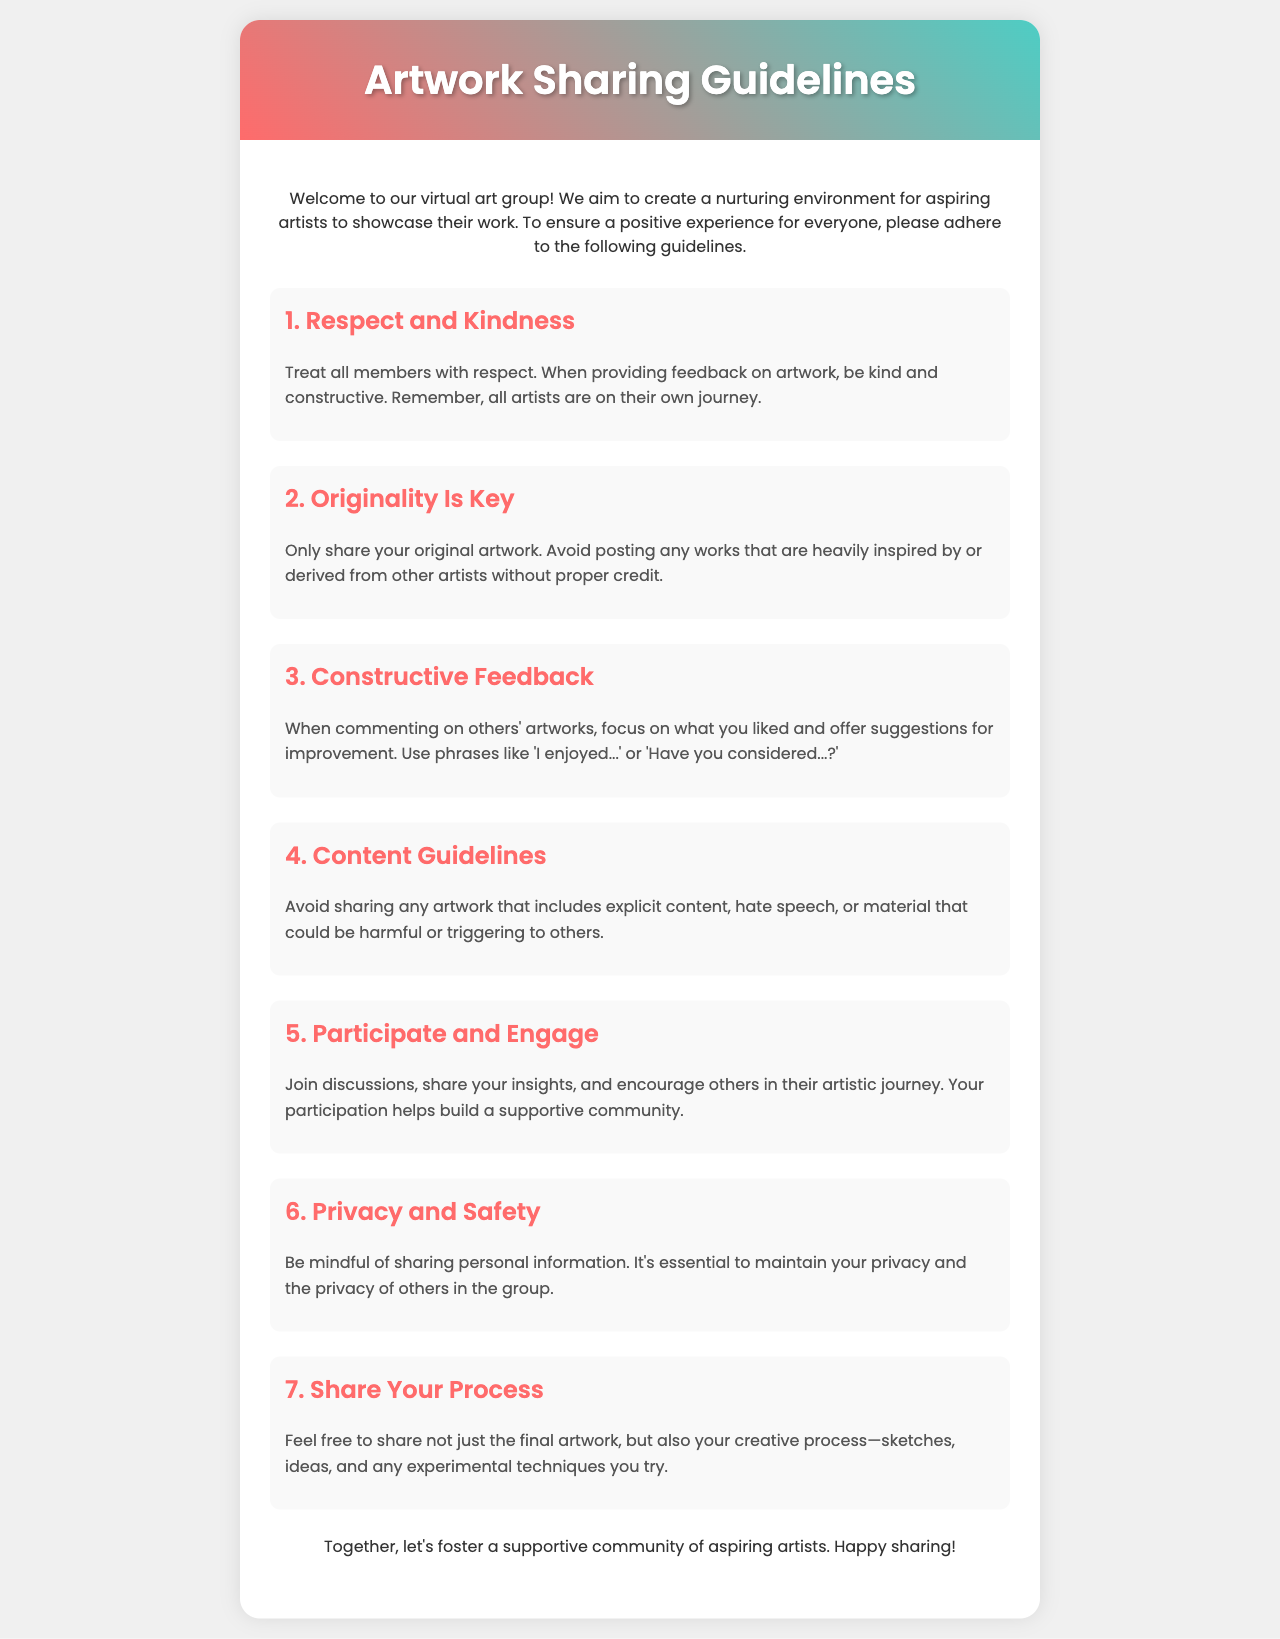What is the title of the document? The title of the document is presented prominently at the top of the brochure.
Answer: Artwork Sharing Guidelines How many sections are there in the guidelines? The document contains several sections that outline the guidelines, specifically listed with headings.
Answer: 7 What is the first guideline about? The first guideline is clearly highlighted, focusing on the treatment of members.
Answer: Respect and Kindness What should feedback on artwork be like? The document specifies how feedback should be delivered when commenting on artwork.
Answer: Kind and constructive What type of content should be avoided in shared artwork? The guidelines specifically mention types of content that are not suitable for sharing.
Answer: Explicit content What does the seventh guideline encourage sharing? The seventh guideline suggests what kind of work to include in contributions beyond final pieces.
Answer: Your creative process What is the main purpose of the document? The overarching goal of the document as outlined in the introduction is to create a certain environment.
Answer: To create a nurturing environment What is mentioned about personal information? The guidelines provide a recommendation regarding personal data that group members should keep in mind.
Answer: Maintain privacy 